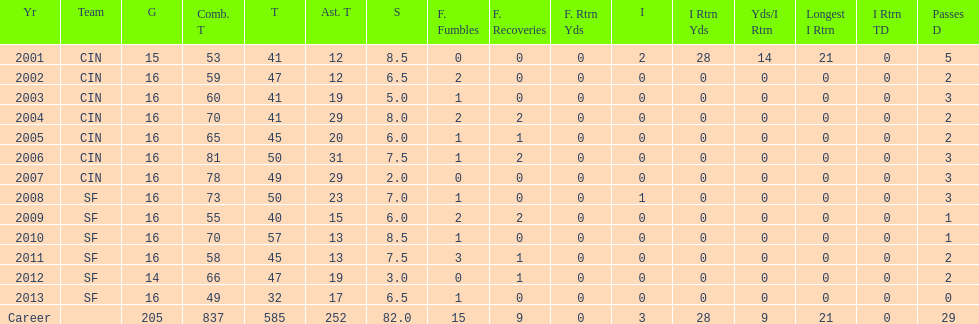How many fumble recoveries did this player have in 2004? 2. 